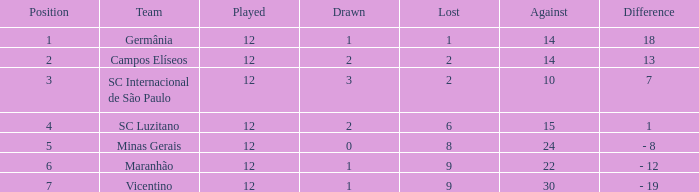Which distinction includes more than 10 points and fewer than 2 draws? 18.0. 